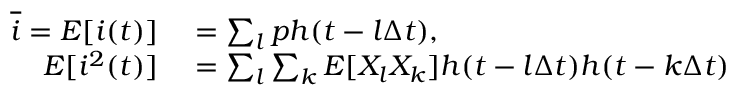<formula> <loc_0><loc_0><loc_500><loc_500>\begin{array} { r l } { \overline { i } = E [ i ( t ) ] } & = \sum _ { l } p h ( t - l \Delta t ) , } \\ { E [ i ^ { 2 } ( t ) ] } & = \sum _ { l } \sum _ { k } E [ X _ { l } X _ { k } ] h ( t - l \Delta t ) h ( t - k \Delta t ) } \end{array}</formula> 